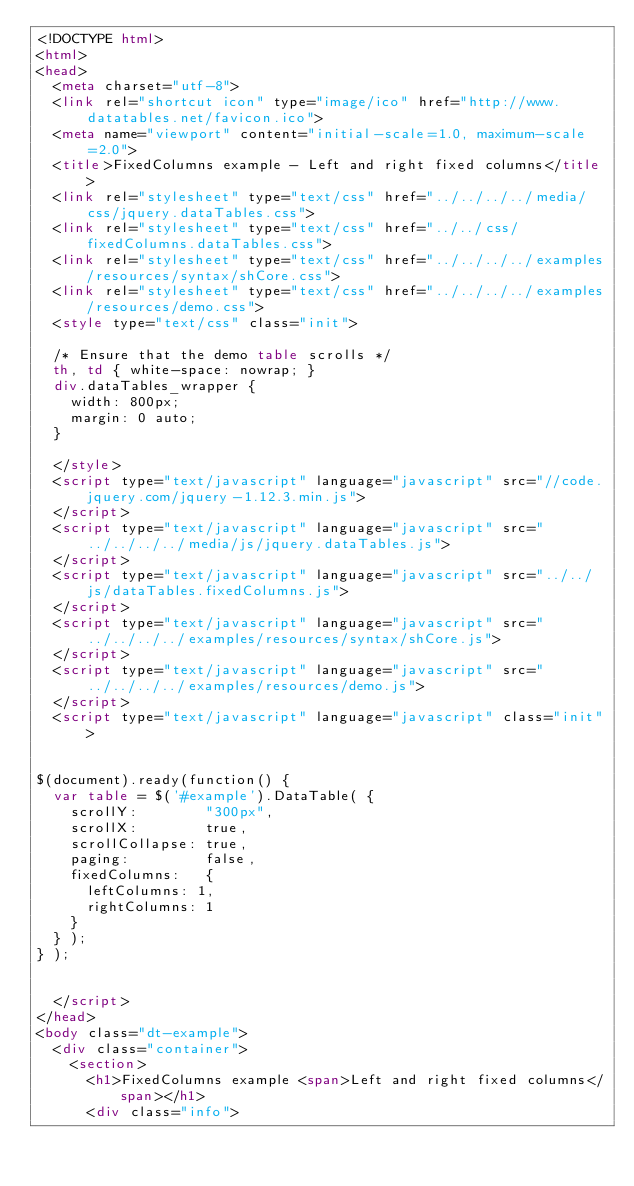<code> <loc_0><loc_0><loc_500><loc_500><_HTML_><!DOCTYPE html>
<html>
<head>
	<meta charset="utf-8">
	<link rel="shortcut icon" type="image/ico" href="http://www.datatables.net/favicon.ico">
	<meta name="viewport" content="initial-scale=1.0, maximum-scale=2.0">
	<title>FixedColumns example - Left and right fixed columns</title>
	<link rel="stylesheet" type="text/css" href="../../../../media/css/jquery.dataTables.css">
	<link rel="stylesheet" type="text/css" href="../../css/fixedColumns.dataTables.css">
	<link rel="stylesheet" type="text/css" href="../../../../examples/resources/syntax/shCore.css">
	<link rel="stylesheet" type="text/css" href="../../../../examples/resources/demo.css">
	<style type="text/css" class="init">
	
	/* Ensure that the demo table scrolls */
	th, td { white-space: nowrap; }
	div.dataTables_wrapper {
		width: 800px;
		margin: 0 auto;
	}

	</style>
	<script type="text/javascript" language="javascript" src="//code.jquery.com/jquery-1.12.3.min.js">
	</script>
	<script type="text/javascript" language="javascript" src="../../../../media/js/jquery.dataTables.js">
	</script>
	<script type="text/javascript" language="javascript" src="../../js/dataTables.fixedColumns.js">
	</script>
	<script type="text/javascript" language="javascript" src="../../../../examples/resources/syntax/shCore.js">
	</script>
	<script type="text/javascript" language="javascript" src="../../../../examples/resources/demo.js">
	</script>
	<script type="text/javascript" language="javascript" class="init">
	

$(document).ready(function() {
	var table = $('#example').DataTable( {
		scrollY:        "300px",
		scrollX:        true,
		scrollCollapse: true,
		paging:         false,
		fixedColumns:   {
			leftColumns: 1,
			rightColumns: 1
		}
	} );
} );


	</script>
</head>
<body class="dt-example">
	<div class="container">
		<section>
			<h1>FixedColumns example <span>Left and right fixed columns</span></h1>
			<div class="info"></code> 